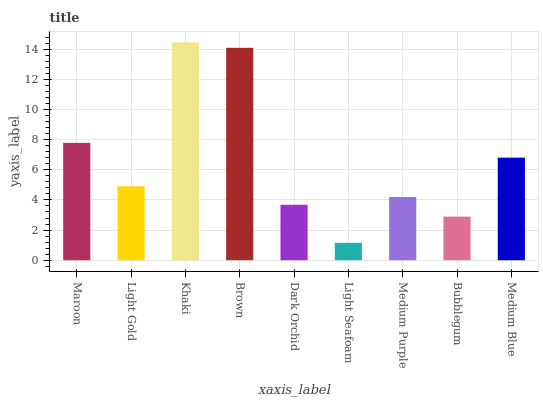Is Light Seafoam the minimum?
Answer yes or no. Yes. Is Khaki the maximum?
Answer yes or no. Yes. Is Light Gold the minimum?
Answer yes or no. No. Is Light Gold the maximum?
Answer yes or no. No. Is Maroon greater than Light Gold?
Answer yes or no. Yes. Is Light Gold less than Maroon?
Answer yes or no. Yes. Is Light Gold greater than Maroon?
Answer yes or no. No. Is Maroon less than Light Gold?
Answer yes or no. No. Is Light Gold the high median?
Answer yes or no. Yes. Is Light Gold the low median?
Answer yes or no. Yes. Is Light Seafoam the high median?
Answer yes or no. No. Is Brown the low median?
Answer yes or no. No. 